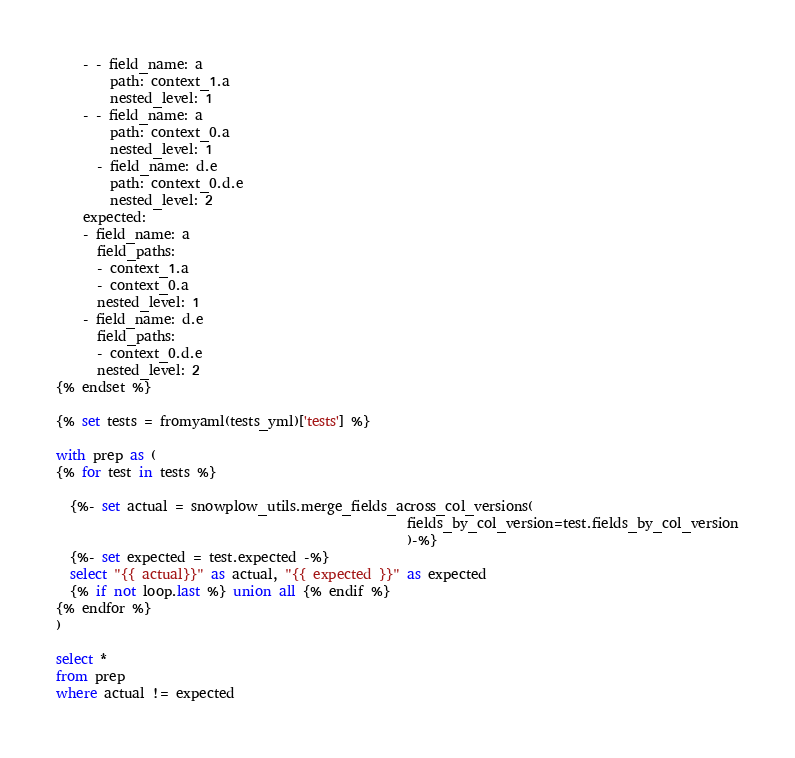<code> <loc_0><loc_0><loc_500><loc_500><_SQL_>    - - field_name: a
        path: context_1.a
        nested_level: 1
    - - field_name: a
        path: context_0.a
        nested_level: 1
      - field_name: d.e
        path: context_0.d.e
        nested_level: 2
    expected:
    - field_name: a
      field_paths:
      - context_1.a
      - context_0.a
      nested_level: 1
    - field_name: d.e
      field_paths:
      - context_0.d.e
      nested_level: 2
{% endset %}

{% set tests = fromyaml(tests_yml)['tests'] %}

with prep as (
{% for test in tests %}

  {%- set actual = snowplow_utils.merge_fields_across_col_versions(
                                                    fields_by_col_version=test.fields_by_col_version
                                                    )-%}
  {%- set expected = test.expected -%}
  select "{{ actual}}" as actual, "{{ expected }}" as expected
  {% if not loop.last %} union all {% endif %}
{% endfor %}
)

select * 
from prep
where actual != expected
</code> 